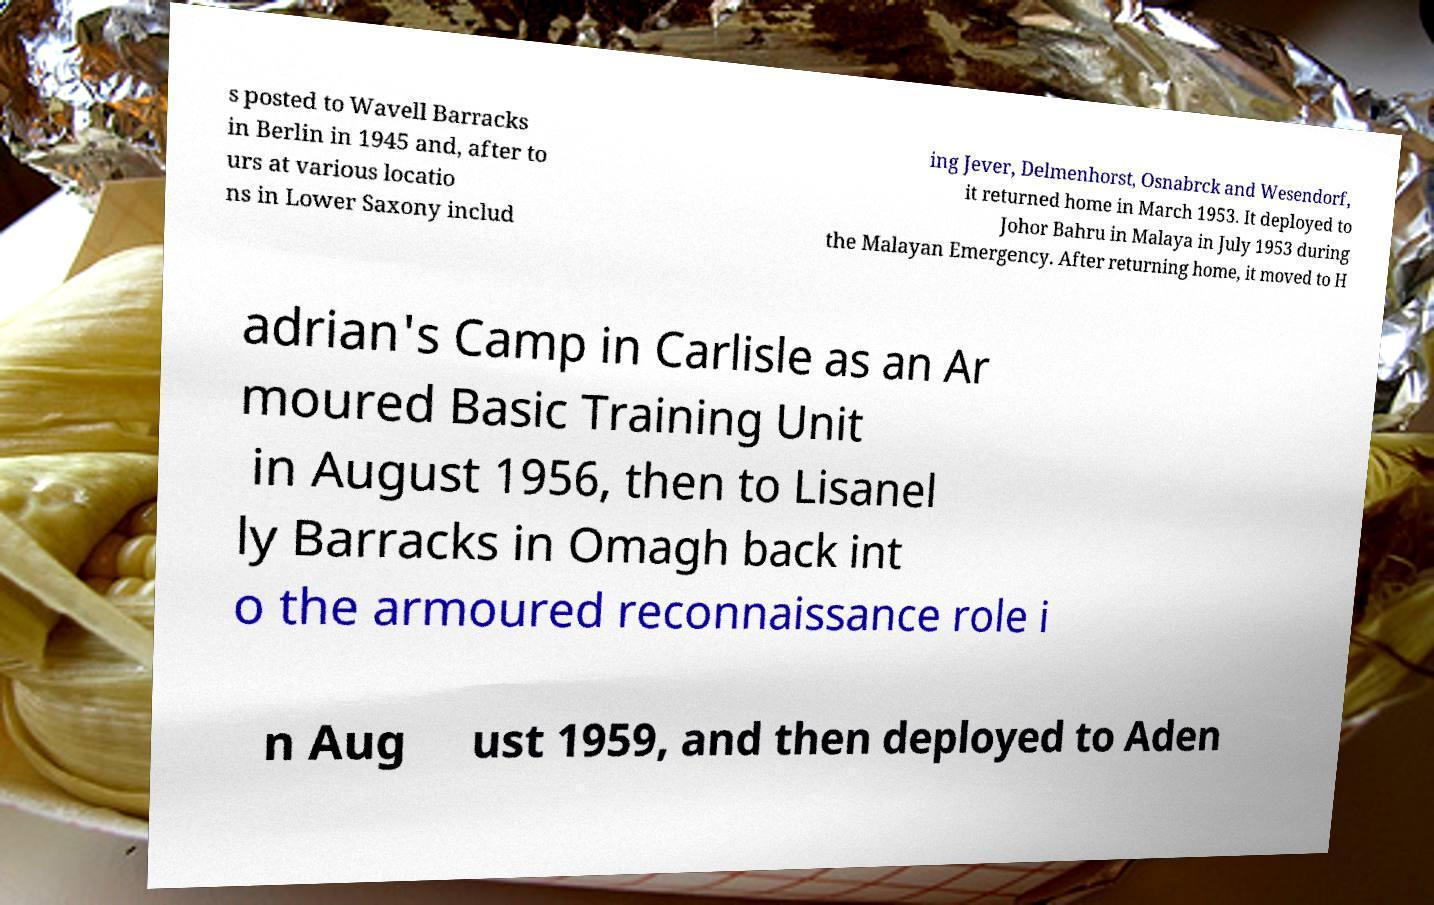I need the written content from this picture converted into text. Can you do that? s posted to Wavell Barracks in Berlin in 1945 and, after to urs at various locatio ns in Lower Saxony includ ing Jever, Delmenhorst, Osnabrck and Wesendorf, it returned home in March 1953. It deployed to Johor Bahru in Malaya in July 1953 during the Malayan Emergency. After returning home, it moved to H adrian's Camp in Carlisle as an Ar moured Basic Training Unit in August 1956, then to Lisanel ly Barracks in Omagh back int o the armoured reconnaissance role i n Aug ust 1959, and then deployed to Aden 